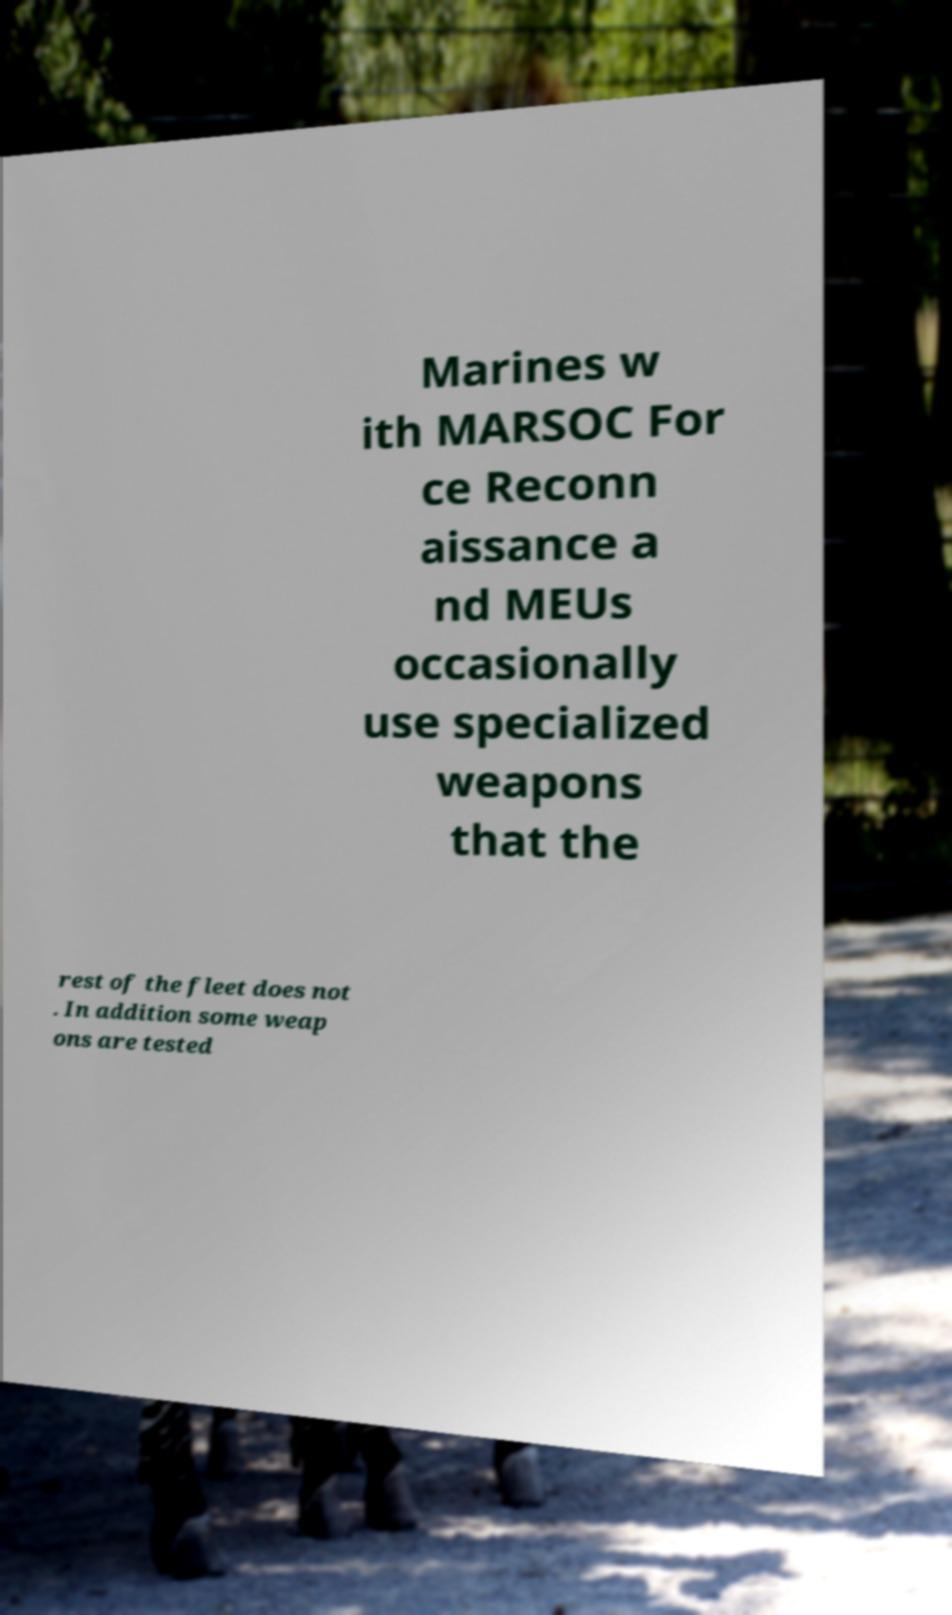There's text embedded in this image that I need extracted. Can you transcribe it verbatim? Marines w ith MARSOC For ce Reconn aissance a nd MEUs occasionally use specialized weapons that the rest of the fleet does not . In addition some weap ons are tested 